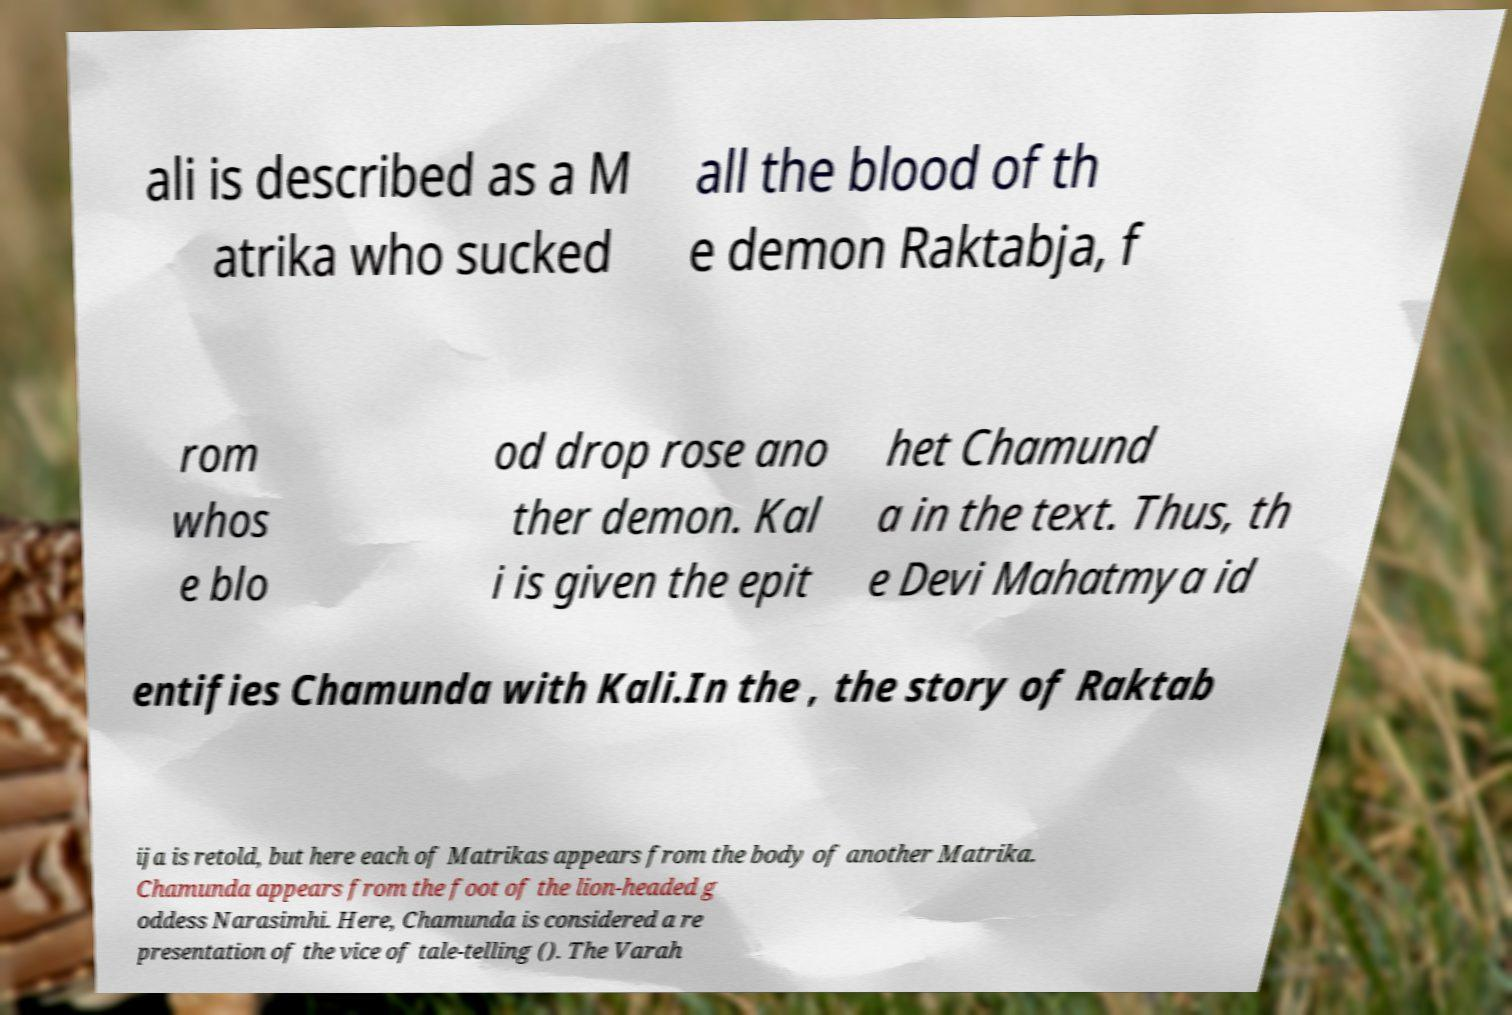Could you extract and type out the text from this image? ali is described as a M atrika who sucked all the blood of th e demon Raktabja, f rom whos e blo od drop rose ano ther demon. Kal i is given the epit het Chamund a in the text. Thus, th e Devi Mahatmya id entifies Chamunda with Kali.In the , the story of Raktab ija is retold, but here each of Matrikas appears from the body of another Matrika. Chamunda appears from the foot of the lion-headed g oddess Narasimhi. Here, Chamunda is considered a re presentation of the vice of tale-telling (). The Varah 